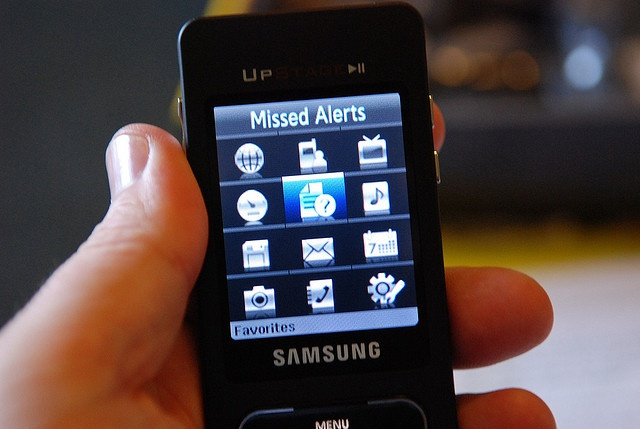Describe the objects in this image and their specific colors. I can see cell phone in black, navy, white, and gray tones and people in black, brown, and maroon tones in this image. 